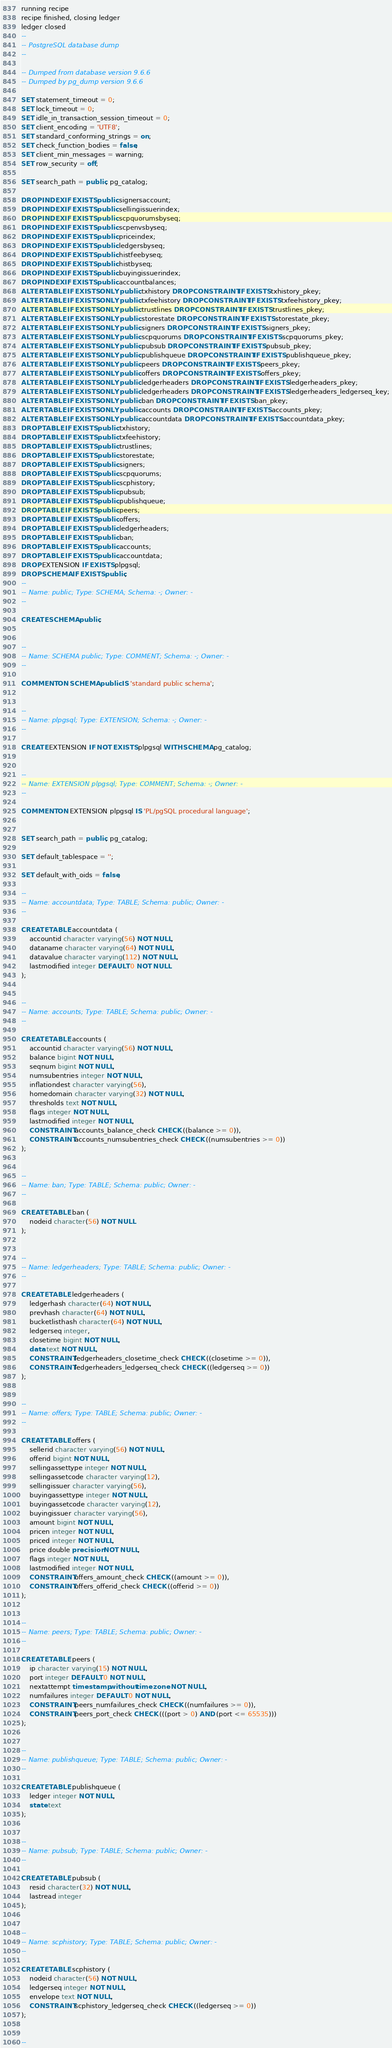Convert code to text. <code><loc_0><loc_0><loc_500><loc_500><_SQL_>running recipe
recipe finished, closing ledger
ledger closed
--
-- PostgreSQL database dump
--

-- Dumped from database version 9.6.6
-- Dumped by pg_dump version 9.6.6

SET statement_timeout = 0;
SET lock_timeout = 0;
SET idle_in_transaction_session_timeout = 0;
SET client_encoding = 'UTF8';
SET standard_conforming_strings = on;
SET check_function_bodies = false;
SET client_min_messages = warning;
SET row_security = off;

SET search_path = public, pg_catalog;

DROP INDEX IF EXISTS public.signersaccount;
DROP INDEX IF EXISTS public.sellingissuerindex;
DROP INDEX IF EXISTS public.scpquorumsbyseq;
DROP INDEX IF EXISTS public.scpenvsbyseq;
DROP INDEX IF EXISTS public.priceindex;
DROP INDEX IF EXISTS public.ledgersbyseq;
DROP INDEX IF EXISTS public.histfeebyseq;
DROP INDEX IF EXISTS public.histbyseq;
DROP INDEX IF EXISTS public.buyingissuerindex;
DROP INDEX IF EXISTS public.accountbalances;
ALTER TABLE IF EXISTS ONLY public.txhistory DROP CONSTRAINT IF EXISTS txhistory_pkey;
ALTER TABLE IF EXISTS ONLY public.txfeehistory DROP CONSTRAINT IF EXISTS txfeehistory_pkey;
ALTER TABLE IF EXISTS ONLY public.trustlines DROP CONSTRAINT IF EXISTS trustlines_pkey;
ALTER TABLE IF EXISTS ONLY public.storestate DROP CONSTRAINT IF EXISTS storestate_pkey;
ALTER TABLE IF EXISTS ONLY public.signers DROP CONSTRAINT IF EXISTS signers_pkey;
ALTER TABLE IF EXISTS ONLY public.scpquorums DROP CONSTRAINT IF EXISTS scpquorums_pkey;
ALTER TABLE IF EXISTS ONLY public.pubsub DROP CONSTRAINT IF EXISTS pubsub_pkey;
ALTER TABLE IF EXISTS ONLY public.publishqueue DROP CONSTRAINT IF EXISTS publishqueue_pkey;
ALTER TABLE IF EXISTS ONLY public.peers DROP CONSTRAINT IF EXISTS peers_pkey;
ALTER TABLE IF EXISTS ONLY public.offers DROP CONSTRAINT IF EXISTS offers_pkey;
ALTER TABLE IF EXISTS ONLY public.ledgerheaders DROP CONSTRAINT IF EXISTS ledgerheaders_pkey;
ALTER TABLE IF EXISTS ONLY public.ledgerheaders DROP CONSTRAINT IF EXISTS ledgerheaders_ledgerseq_key;
ALTER TABLE IF EXISTS ONLY public.ban DROP CONSTRAINT IF EXISTS ban_pkey;
ALTER TABLE IF EXISTS ONLY public.accounts DROP CONSTRAINT IF EXISTS accounts_pkey;
ALTER TABLE IF EXISTS ONLY public.accountdata DROP CONSTRAINT IF EXISTS accountdata_pkey;
DROP TABLE IF EXISTS public.txhistory;
DROP TABLE IF EXISTS public.txfeehistory;
DROP TABLE IF EXISTS public.trustlines;
DROP TABLE IF EXISTS public.storestate;
DROP TABLE IF EXISTS public.signers;
DROP TABLE IF EXISTS public.scpquorums;
DROP TABLE IF EXISTS public.scphistory;
DROP TABLE IF EXISTS public.pubsub;
DROP TABLE IF EXISTS public.publishqueue;
DROP TABLE IF EXISTS public.peers;
DROP TABLE IF EXISTS public.offers;
DROP TABLE IF EXISTS public.ledgerheaders;
DROP TABLE IF EXISTS public.ban;
DROP TABLE IF EXISTS public.accounts;
DROP TABLE IF EXISTS public.accountdata;
DROP EXTENSION IF EXISTS plpgsql;
DROP SCHEMA IF EXISTS public;
--
-- Name: public; Type: SCHEMA; Schema: -; Owner: -
--

CREATE SCHEMA public;


--
-- Name: SCHEMA public; Type: COMMENT; Schema: -; Owner: -
--

COMMENT ON SCHEMA public IS 'standard public schema';


--
-- Name: plpgsql; Type: EXTENSION; Schema: -; Owner: -
--

CREATE EXTENSION IF NOT EXISTS plpgsql WITH SCHEMA pg_catalog;


--
-- Name: EXTENSION plpgsql; Type: COMMENT; Schema: -; Owner: -
--

COMMENT ON EXTENSION plpgsql IS 'PL/pgSQL procedural language';


SET search_path = public, pg_catalog;

SET default_tablespace = '';

SET default_with_oids = false;

--
-- Name: accountdata; Type: TABLE; Schema: public; Owner: -
--

CREATE TABLE accountdata (
    accountid character varying(56) NOT NULL,
    dataname character varying(64) NOT NULL,
    datavalue character varying(112) NOT NULL,
    lastmodified integer DEFAULT 0 NOT NULL
);


--
-- Name: accounts; Type: TABLE; Schema: public; Owner: -
--

CREATE TABLE accounts (
    accountid character varying(56) NOT NULL,
    balance bigint NOT NULL,
    seqnum bigint NOT NULL,
    numsubentries integer NOT NULL,
    inflationdest character varying(56),
    homedomain character varying(32) NOT NULL,
    thresholds text NOT NULL,
    flags integer NOT NULL,
    lastmodified integer NOT NULL,
    CONSTRAINT accounts_balance_check CHECK ((balance >= 0)),
    CONSTRAINT accounts_numsubentries_check CHECK ((numsubentries >= 0))
);


--
-- Name: ban; Type: TABLE; Schema: public; Owner: -
--

CREATE TABLE ban (
    nodeid character(56) NOT NULL
);


--
-- Name: ledgerheaders; Type: TABLE; Schema: public; Owner: -
--

CREATE TABLE ledgerheaders (
    ledgerhash character(64) NOT NULL,
    prevhash character(64) NOT NULL,
    bucketlisthash character(64) NOT NULL,
    ledgerseq integer,
    closetime bigint NOT NULL,
    data text NOT NULL,
    CONSTRAINT ledgerheaders_closetime_check CHECK ((closetime >= 0)),
    CONSTRAINT ledgerheaders_ledgerseq_check CHECK ((ledgerseq >= 0))
);


--
-- Name: offers; Type: TABLE; Schema: public; Owner: -
--

CREATE TABLE offers (
    sellerid character varying(56) NOT NULL,
    offerid bigint NOT NULL,
    sellingassettype integer NOT NULL,
    sellingassetcode character varying(12),
    sellingissuer character varying(56),
    buyingassettype integer NOT NULL,
    buyingassetcode character varying(12),
    buyingissuer character varying(56),
    amount bigint NOT NULL,
    pricen integer NOT NULL,
    priced integer NOT NULL,
    price double precision NOT NULL,
    flags integer NOT NULL,
    lastmodified integer NOT NULL,
    CONSTRAINT offers_amount_check CHECK ((amount >= 0)),
    CONSTRAINT offers_offerid_check CHECK ((offerid >= 0))
);


--
-- Name: peers; Type: TABLE; Schema: public; Owner: -
--

CREATE TABLE peers (
    ip character varying(15) NOT NULL,
    port integer DEFAULT 0 NOT NULL,
    nextattempt timestamp without time zone NOT NULL,
    numfailures integer DEFAULT 0 NOT NULL,
    CONSTRAINT peers_numfailures_check CHECK ((numfailures >= 0)),
    CONSTRAINT peers_port_check CHECK (((port > 0) AND (port <= 65535)))
);


--
-- Name: publishqueue; Type: TABLE; Schema: public; Owner: -
--

CREATE TABLE publishqueue (
    ledger integer NOT NULL,
    state text
);


--
-- Name: pubsub; Type: TABLE; Schema: public; Owner: -
--

CREATE TABLE pubsub (
    resid character(32) NOT NULL,
    lastread integer
);


--
-- Name: scphistory; Type: TABLE; Schema: public; Owner: -
--

CREATE TABLE scphistory (
    nodeid character(56) NOT NULL,
    ledgerseq integer NOT NULL,
    envelope text NOT NULL,
    CONSTRAINT scphistory_ledgerseq_check CHECK ((ledgerseq >= 0))
);


--</code> 